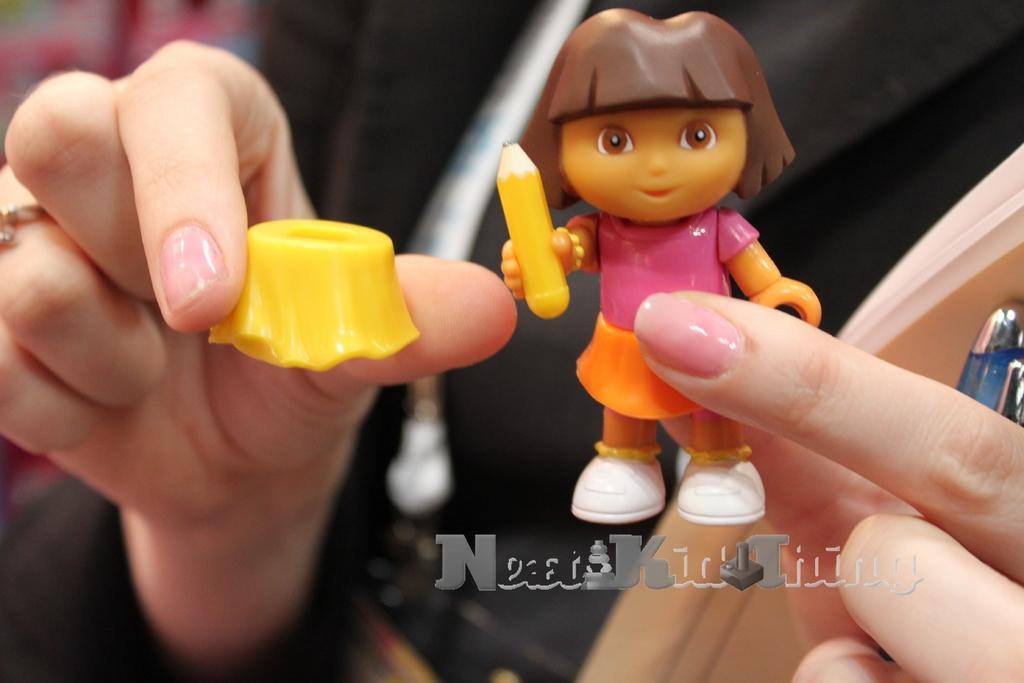How would you summarize this image in a sentence or two? In this picture we can see a person holding toys and a pen. The background is not clear. At the bottom there is text. 